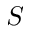<formula> <loc_0><loc_0><loc_500><loc_500>S</formula> 